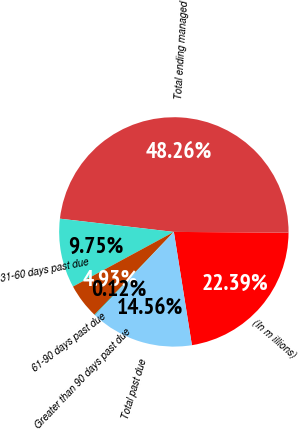<chart> <loc_0><loc_0><loc_500><loc_500><pie_chart><fcel>(In m illions)<fcel>Total ending managed<fcel>31-60 days past due<fcel>61-90 days past due<fcel>Greater than 90 days past due<fcel>Total past due<nl><fcel>22.39%<fcel>48.26%<fcel>9.75%<fcel>4.93%<fcel>0.12%<fcel>14.56%<nl></chart> 